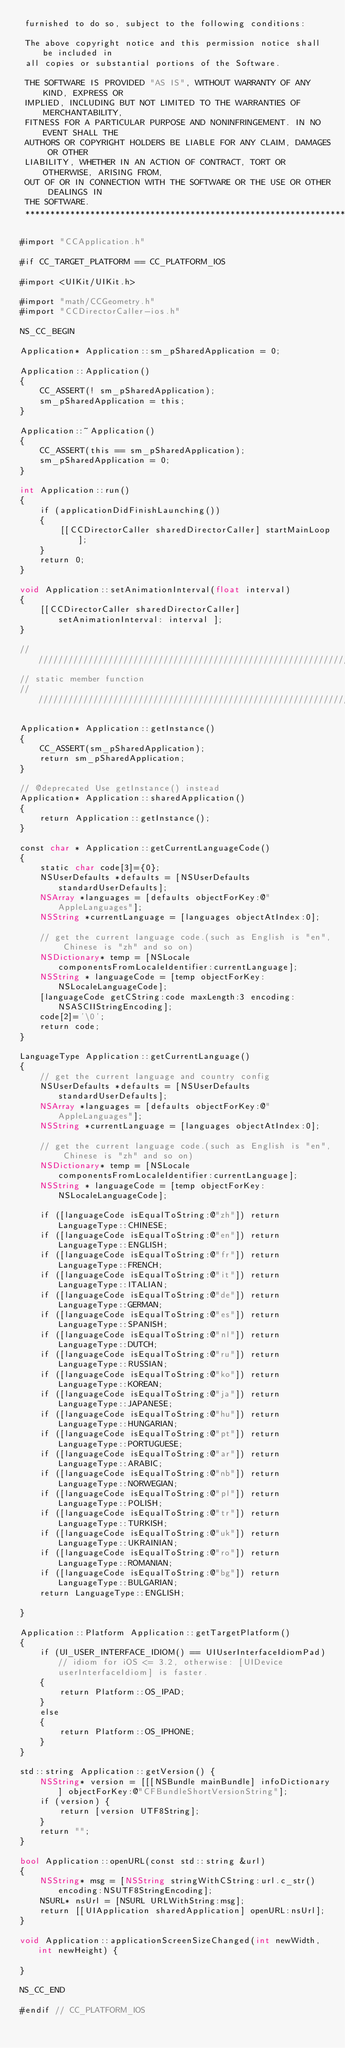Convert code to text. <code><loc_0><loc_0><loc_500><loc_500><_ObjectiveC_> furnished to do so, subject to the following conditions:
 
 The above copyright notice and this permission notice shall be included in
 all copies or substantial portions of the Software.
 
 THE SOFTWARE IS PROVIDED "AS IS", WITHOUT WARRANTY OF ANY KIND, EXPRESS OR
 IMPLIED, INCLUDING BUT NOT LIMITED TO THE WARRANTIES OF MERCHANTABILITY,
 FITNESS FOR A PARTICULAR PURPOSE AND NONINFRINGEMENT. IN NO EVENT SHALL THE
 AUTHORS OR COPYRIGHT HOLDERS BE LIABLE FOR ANY CLAIM, DAMAGES OR OTHER
 LIABILITY, WHETHER IN AN ACTION OF CONTRACT, TORT OR OTHERWISE, ARISING FROM,
 OUT OF OR IN CONNECTION WITH THE SOFTWARE OR THE USE OR OTHER DEALINGS IN
 THE SOFTWARE.
 ****************************************************************************/

#import "CCApplication.h"

#if CC_TARGET_PLATFORM == CC_PLATFORM_IOS

#import <UIKit/UIKit.h>

#import "math/CCGeometry.h"
#import "CCDirectorCaller-ios.h"

NS_CC_BEGIN

Application* Application::sm_pSharedApplication = 0;

Application::Application()
{
    CC_ASSERT(! sm_pSharedApplication);
    sm_pSharedApplication = this;
}

Application::~Application()
{
    CC_ASSERT(this == sm_pSharedApplication);
    sm_pSharedApplication = 0;
}

int Application::run()
{
    if (applicationDidFinishLaunching()) 
    {
        [[CCDirectorCaller sharedDirectorCaller] startMainLoop];
    }
    return 0;
}

void Application::setAnimationInterval(float interval)
{
    [[CCDirectorCaller sharedDirectorCaller] setAnimationInterval: interval ];
}

/////////////////////////////////////////////////////////////////////////////////////////////////
// static member function
//////////////////////////////////////////////////////////////////////////////////////////////////

Application* Application::getInstance()
{
    CC_ASSERT(sm_pSharedApplication);
    return sm_pSharedApplication;
}

// @deprecated Use getInstance() instead
Application* Application::sharedApplication()
{
    return Application::getInstance();
}

const char * Application::getCurrentLanguageCode()
{
    static char code[3]={0};
    NSUserDefaults *defaults = [NSUserDefaults standardUserDefaults];
    NSArray *languages = [defaults objectForKey:@"AppleLanguages"];
    NSString *currentLanguage = [languages objectAtIndex:0];
    
    // get the current language code.(such as English is "en", Chinese is "zh" and so on)
    NSDictionary* temp = [NSLocale componentsFromLocaleIdentifier:currentLanguage];
    NSString * languageCode = [temp objectForKey:NSLocaleLanguageCode];
    [languageCode getCString:code maxLength:3 encoding:NSASCIIStringEncoding];
    code[2]='\0';
    return code;
}

LanguageType Application::getCurrentLanguage()
{
    // get the current language and country config
    NSUserDefaults *defaults = [NSUserDefaults standardUserDefaults];
    NSArray *languages = [defaults objectForKey:@"AppleLanguages"];
    NSString *currentLanguage = [languages objectAtIndex:0];
    
    // get the current language code.(such as English is "en", Chinese is "zh" and so on)
    NSDictionary* temp = [NSLocale componentsFromLocaleIdentifier:currentLanguage];
    NSString * languageCode = [temp objectForKey:NSLocaleLanguageCode];
    
    if ([languageCode isEqualToString:@"zh"]) return LanguageType::CHINESE;
    if ([languageCode isEqualToString:@"en"]) return LanguageType::ENGLISH;
    if ([languageCode isEqualToString:@"fr"]) return LanguageType::FRENCH;
    if ([languageCode isEqualToString:@"it"]) return LanguageType::ITALIAN;
    if ([languageCode isEqualToString:@"de"]) return LanguageType::GERMAN;
    if ([languageCode isEqualToString:@"es"]) return LanguageType::SPANISH;
    if ([languageCode isEqualToString:@"nl"]) return LanguageType::DUTCH;
    if ([languageCode isEqualToString:@"ru"]) return LanguageType::RUSSIAN;
    if ([languageCode isEqualToString:@"ko"]) return LanguageType::KOREAN;
    if ([languageCode isEqualToString:@"ja"]) return LanguageType::JAPANESE;
    if ([languageCode isEqualToString:@"hu"]) return LanguageType::HUNGARIAN;
    if ([languageCode isEqualToString:@"pt"]) return LanguageType::PORTUGUESE;
    if ([languageCode isEqualToString:@"ar"]) return LanguageType::ARABIC;
    if ([languageCode isEqualToString:@"nb"]) return LanguageType::NORWEGIAN;
    if ([languageCode isEqualToString:@"pl"]) return LanguageType::POLISH;
    if ([languageCode isEqualToString:@"tr"]) return LanguageType::TURKISH;
    if ([languageCode isEqualToString:@"uk"]) return LanguageType::UKRAINIAN;
    if ([languageCode isEqualToString:@"ro"]) return LanguageType::ROMANIAN;
    if ([languageCode isEqualToString:@"bg"]) return LanguageType::BULGARIAN;
    return LanguageType::ENGLISH;

}

Application::Platform Application::getTargetPlatform()
{
    if (UI_USER_INTERFACE_IDIOM() == UIUserInterfaceIdiomPad) // idiom for iOS <= 3.2, otherwise: [UIDevice userInterfaceIdiom] is faster.
    {
        return Platform::OS_IPAD;
    }
    else 
    {
        return Platform::OS_IPHONE;
    }
}

std::string Application::getVersion() {
    NSString* version = [[[NSBundle mainBundle] infoDictionary] objectForKey:@"CFBundleShortVersionString"];
    if (version) {
        return [version UTF8String];
    }
    return "";
}

bool Application::openURL(const std::string &url)
{
    NSString* msg = [NSString stringWithCString:url.c_str() encoding:NSUTF8StringEncoding];
    NSURL* nsUrl = [NSURL URLWithString:msg];
    return [[UIApplication sharedApplication] openURL:nsUrl];
}

void Application::applicationScreenSizeChanged(int newWidth, int newHeight) {

}

NS_CC_END

#endif // CC_PLATFORM_IOS
</code> 